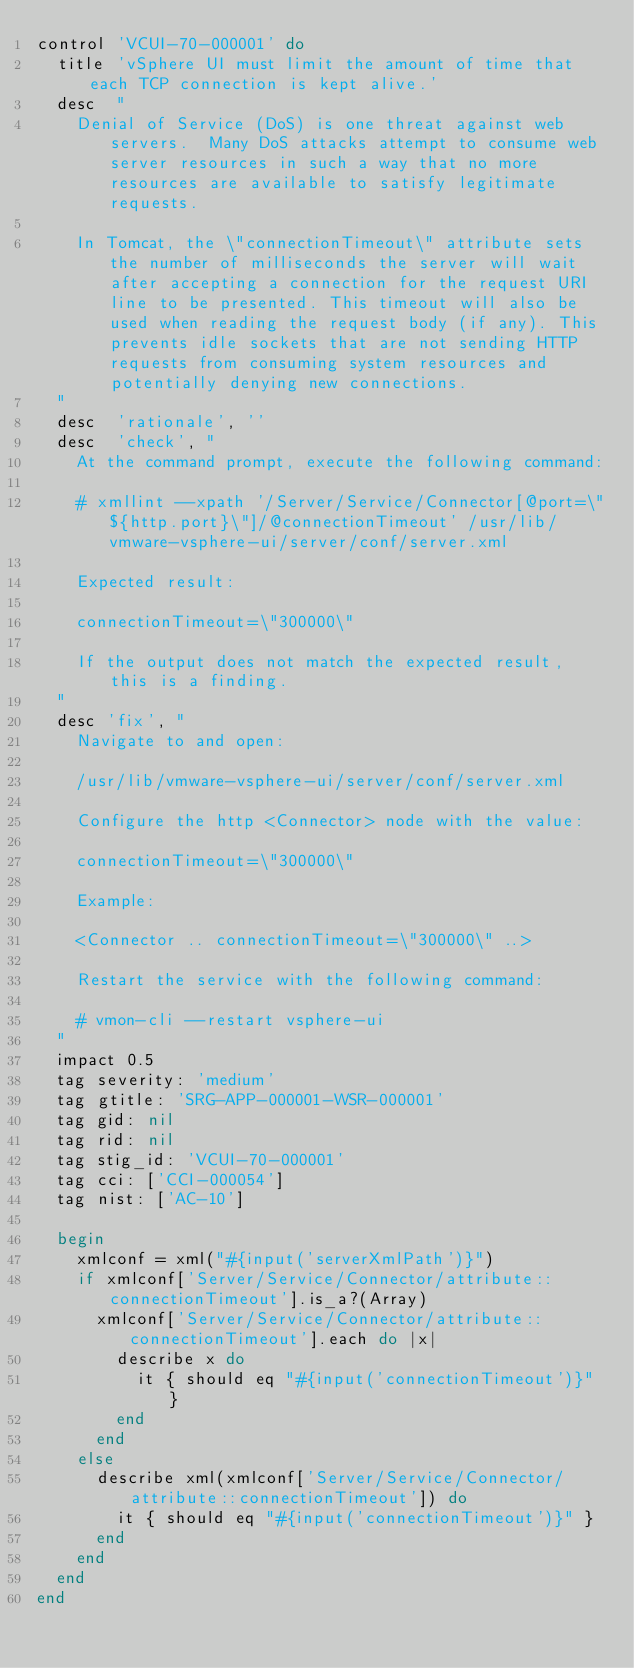<code> <loc_0><loc_0><loc_500><loc_500><_Ruby_>control 'VCUI-70-000001' do
  title 'vSphere UI must limit the amount of time that each TCP connection is kept alive.'
  desc  "
    Denial of Service (DoS) is one threat against web servers.  Many DoS attacks attempt to consume web server resources in such a way that no more resources are available to satisfy legitimate requests.

    In Tomcat, the \"connectionTimeout\" attribute sets the number of milliseconds the server will wait after accepting a connection for the request URI line to be presented. This timeout will also be used when reading the request body (if any). This prevents idle sockets that are not sending HTTP requests from consuming system resources and potentially denying new connections.
  "
  desc  'rationale', ''
  desc  'check', "
    At the command prompt, execute the following command:

    # xmllint --xpath '/Server/Service/Connector[@port=\"${http.port}\"]/@connectionTimeout' /usr/lib/vmware-vsphere-ui/server/conf/server.xml

    Expected result:

    connectionTimeout=\"300000\"

    If the output does not match the expected result, this is a finding.
  "
  desc 'fix', "
    Navigate to and open:

    /usr/lib/vmware-vsphere-ui/server/conf/server.xml

    Configure the http <Connector> node with the value:

    connectionTimeout=\"300000\"

    Example:

    <Connector .. connectionTimeout=\"300000\" ..>

    Restart the service with the following command:

    # vmon-cli --restart vsphere-ui
  "
  impact 0.5
  tag severity: 'medium'
  tag gtitle: 'SRG-APP-000001-WSR-000001'
  tag gid: nil
  tag rid: nil
  tag stig_id: 'VCUI-70-000001'
  tag cci: ['CCI-000054']
  tag nist: ['AC-10']

  begin
    xmlconf = xml("#{input('serverXmlPath')}")
    if xmlconf['Server/Service/Connector/attribute::connectionTimeout'].is_a?(Array)
      xmlconf['Server/Service/Connector/attribute::connectionTimeout'].each do |x|
        describe x do
          it { should eq "#{input('connectionTimeout')}" }
        end
      end
    else
      describe xml(xmlconf['Server/Service/Connector/attribute::connectionTimeout']) do
        it { should eq "#{input('connectionTimeout')}" }
      end
    end
  end
end
</code> 